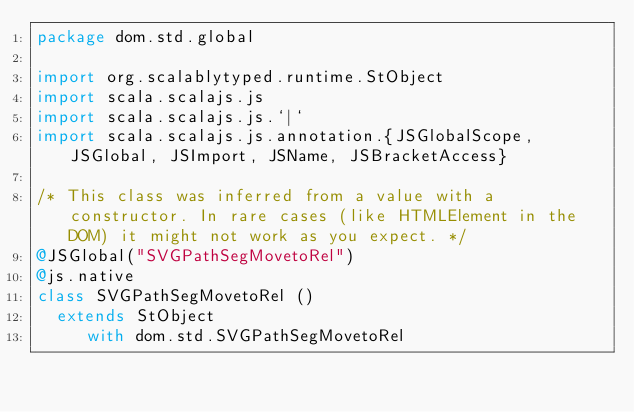<code> <loc_0><loc_0><loc_500><loc_500><_Scala_>package dom.std.global

import org.scalablytyped.runtime.StObject
import scala.scalajs.js
import scala.scalajs.js.`|`
import scala.scalajs.js.annotation.{JSGlobalScope, JSGlobal, JSImport, JSName, JSBracketAccess}

/* This class was inferred from a value with a constructor. In rare cases (like HTMLElement in the DOM) it might not work as you expect. */
@JSGlobal("SVGPathSegMovetoRel")
@js.native
class SVGPathSegMovetoRel ()
  extends StObject
     with dom.std.SVGPathSegMovetoRel
</code> 